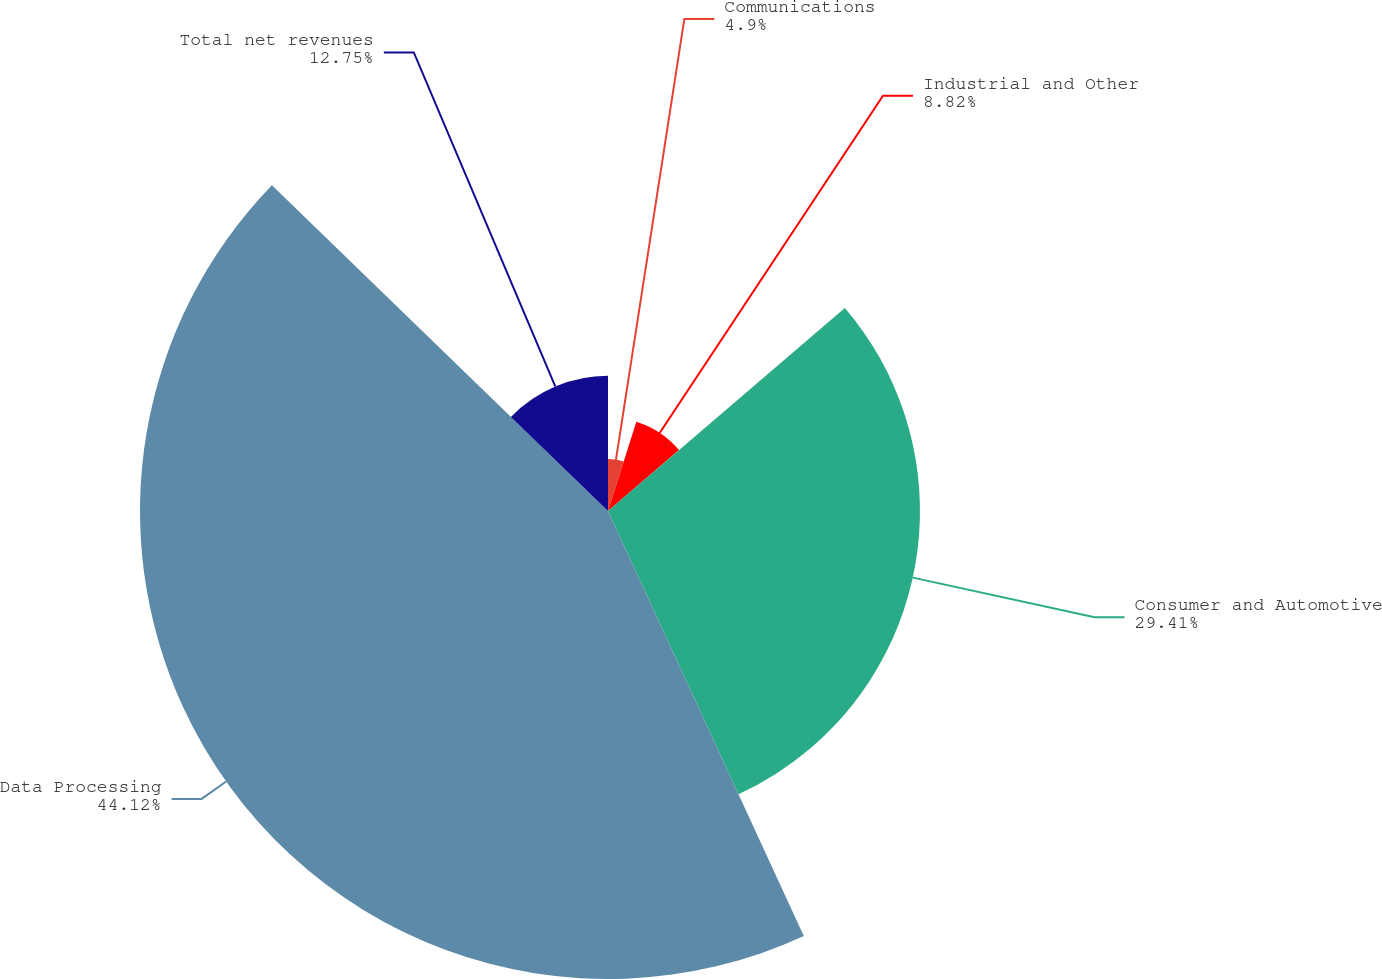Convert chart to OTSL. <chart><loc_0><loc_0><loc_500><loc_500><pie_chart><fcel>Communications<fcel>Industrial and Other<fcel>Consumer and Automotive<fcel>Data Processing<fcel>Total net revenues<nl><fcel>4.9%<fcel>8.82%<fcel>29.41%<fcel>44.12%<fcel>12.75%<nl></chart> 